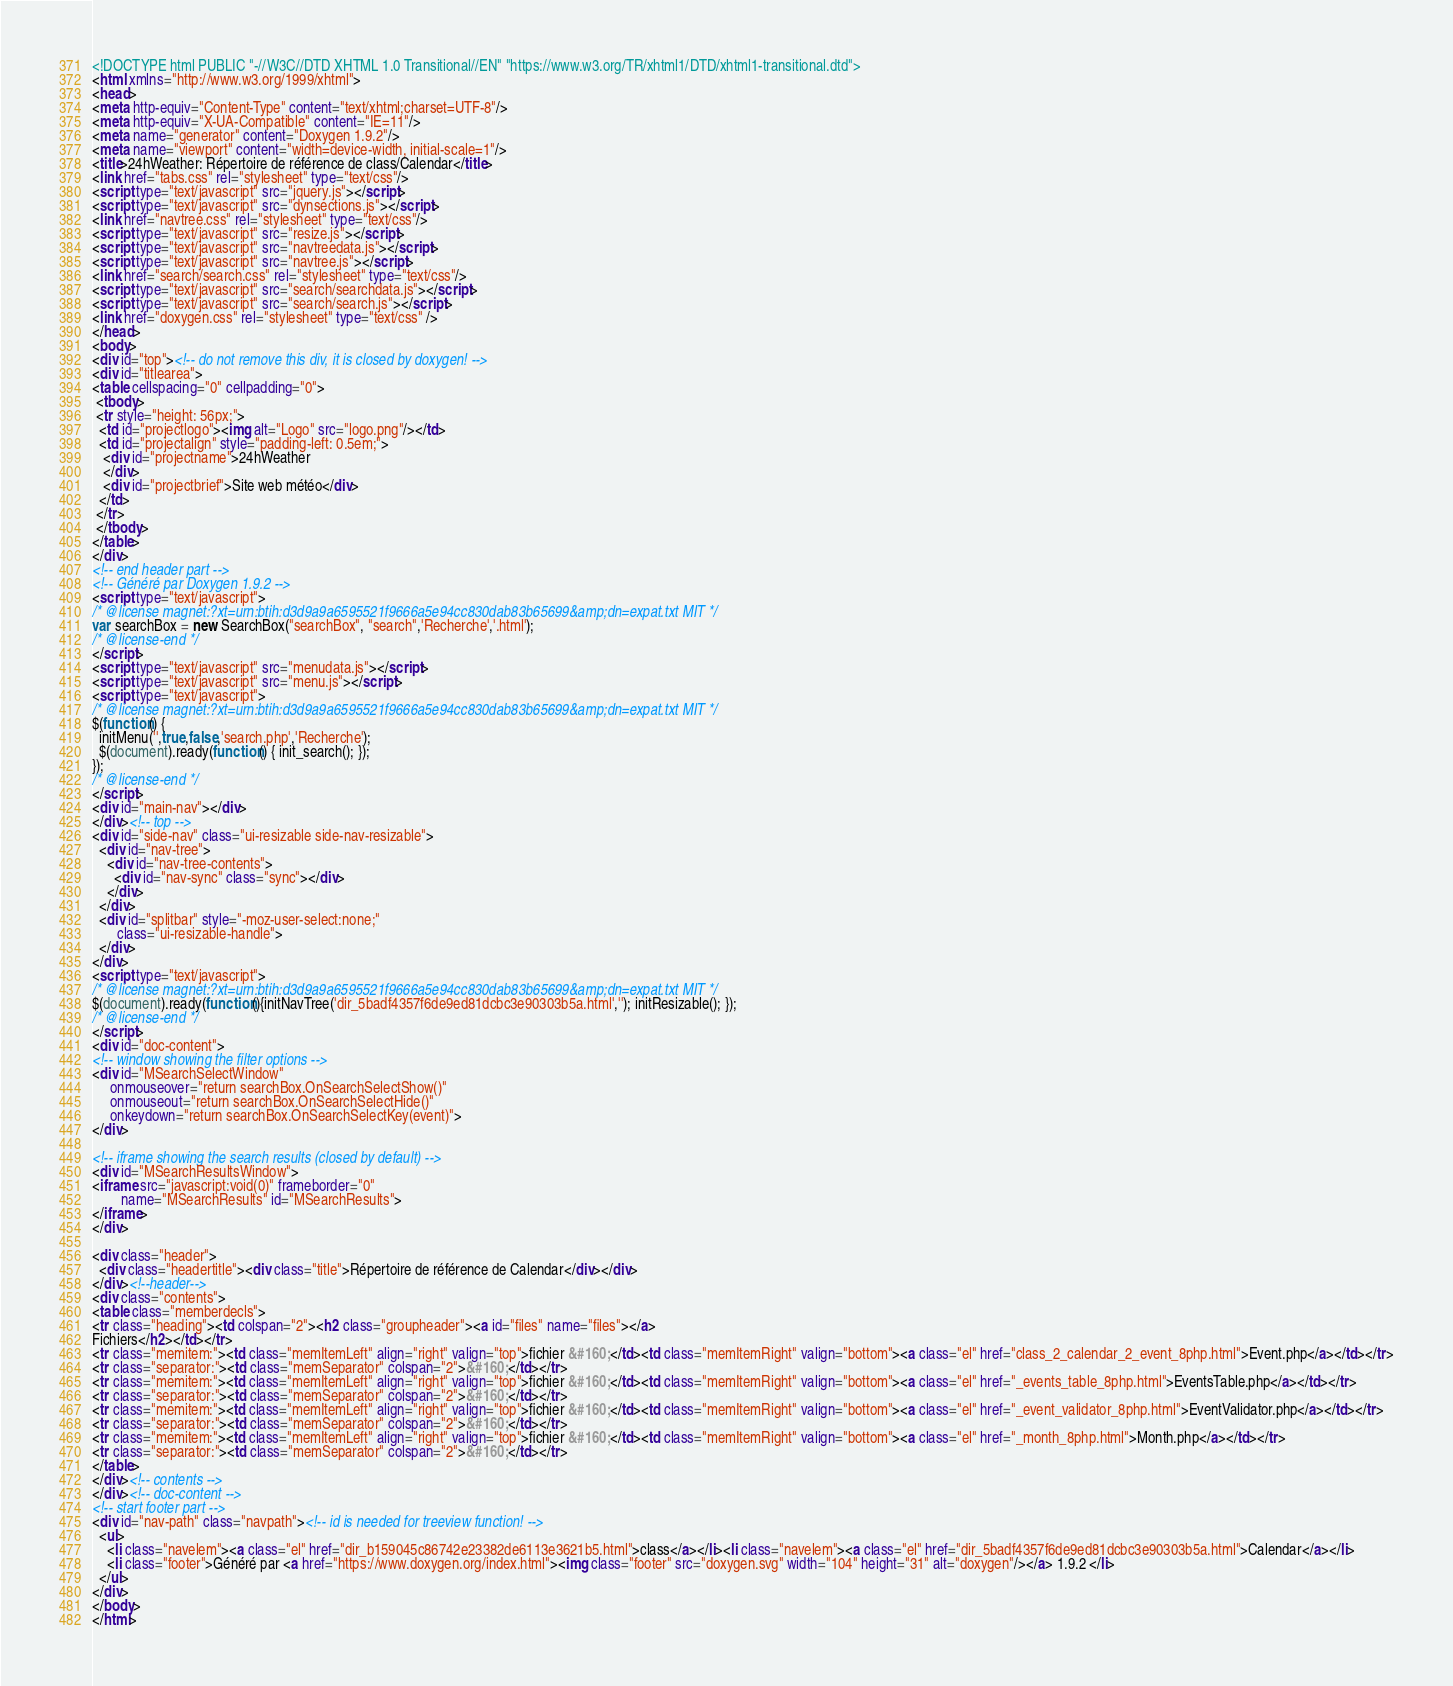Convert code to text. <code><loc_0><loc_0><loc_500><loc_500><_HTML_><!DOCTYPE html PUBLIC "-//W3C//DTD XHTML 1.0 Transitional//EN" "https://www.w3.org/TR/xhtml1/DTD/xhtml1-transitional.dtd">
<html xmlns="http://www.w3.org/1999/xhtml">
<head>
<meta http-equiv="Content-Type" content="text/xhtml;charset=UTF-8"/>
<meta http-equiv="X-UA-Compatible" content="IE=11"/>
<meta name="generator" content="Doxygen 1.9.2"/>
<meta name="viewport" content="width=device-width, initial-scale=1"/>
<title>24hWeather: Répertoire de référence de class/Calendar</title>
<link href="tabs.css" rel="stylesheet" type="text/css"/>
<script type="text/javascript" src="jquery.js"></script>
<script type="text/javascript" src="dynsections.js"></script>
<link href="navtree.css" rel="stylesheet" type="text/css"/>
<script type="text/javascript" src="resize.js"></script>
<script type="text/javascript" src="navtreedata.js"></script>
<script type="text/javascript" src="navtree.js"></script>
<link href="search/search.css" rel="stylesheet" type="text/css"/>
<script type="text/javascript" src="search/searchdata.js"></script>
<script type="text/javascript" src="search/search.js"></script>
<link href="doxygen.css" rel="stylesheet" type="text/css" />
</head>
<body>
<div id="top"><!-- do not remove this div, it is closed by doxygen! -->
<div id="titlearea">
<table cellspacing="0" cellpadding="0">
 <tbody>
 <tr style="height: 56px;">
  <td id="projectlogo"><img alt="Logo" src="logo.png"/></td>
  <td id="projectalign" style="padding-left: 0.5em;">
   <div id="projectname">24hWeather
   </div>
   <div id="projectbrief">Site web météo</div>
  </td>
 </tr>
 </tbody>
</table>
</div>
<!-- end header part -->
<!-- Généré par Doxygen 1.9.2 -->
<script type="text/javascript">
/* @license magnet:?xt=urn:btih:d3d9a9a6595521f9666a5e94cc830dab83b65699&amp;dn=expat.txt MIT */
var searchBox = new SearchBox("searchBox", "search",'Recherche','.html');
/* @license-end */
</script>
<script type="text/javascript" src="menudata.js"></script>
<script type="text/javascript" src="menu.js"></script>
<script type="text/javascript">
/* @license magnet:?xt=urn:btih:d3d9a9a6595521f9666a5e94cc830dab83b65699&amp;dn=expat.txt MIT */
$(function() {
  initMenu('',true,false,'search.php','Recherche');
  $(document).ready(function() { init_search(); });
});
/* @license-end */
</script>
<div id="main-nav"></div>
</div><!-- top -->
<div id="side-nav" class="ui-resizable side-nav-resizable">
  <div id="nav-tree">
    <div id="nav-tree-contents">
      <div id="nav-sync" class="sync"></div>
    </div>
  </div>
  <div id="splitbar" style="-moz-user-select:none;" 
       class="ui-resizable-handle">
  </div>
</div>
<script type="text/javascript">
/* @license magnet:?xt=urn:btih:d3d9a9a6595521f9666a5e94cc830dab83b65699&amp;dn=expat.txt MIT */
$(document).ready(function(){initNavTree('dir_5badf4357f6de9ed81dcbc3e90303b5a.html',''); initResizable(); });
/* @license-end */
</script>
<div id="doc-content">
<!-- window showing the filter options -->
<div id="MSearchSelectWindow"
     onmouseover="return searchBox.OnSearchSelectShow()"
     onmouseout="return searchBox.OnSearchSelectHide()"
     onkeydown="return searchBox.OnSearchSelectKey(event)">
</div>

<!-- iframe showing the search results (closed by default) -->
<div id="MSearchResultsWindow">
<iframe src="javascript:void(0)" frameborder="0" 
        name="MSearchResults" id="MSearchResults">
</iframe>
</div>

<div class="header">
  <div class="headertitle"><div class="title">Répertoire de référence de Calendar</div></div>
</div><!--header-->
<div class="contents">
<table class="memberdecls">
<tr class="heading"><td colspan="2"><h2 class="groupheader"><a id="files" name="files"></a>
Fichiers</h2></td></tr>
<tr class="memitem:"><td class="memItemLeft" align="right" valign="top">fichier &#160;</td><td class="memItemRight" valign="bottom"><a class="el" href="class_2_calendar_2_event_8php.html">Event.php</a></td></tr>
<tr class="separator:"><td class="memSeparator" colspan="2">&#160;</td></tr>
<tr class="memitem:"><td class="memItemLeft" align="right" valign="top">fichier &#160;</td><td class="memItemRight" valign="bottom"><a class="el" href="_events_table_8php.html">EventsTable.php</a></td></tr>
<tr class="separator:"><td class="memSeparator" colspan="2">&#160;</td></tr>
<tr class="memitem:"><td class="memItemLeft" align="right" valign="top">fichier &#160;</td><td class="memItemRight" valign="bottom"><a class="el" href="_event_validator_8php.html">EventValidator.php</a></td></tr>
<tr class="separator:"><td class="memSeparator" colspan="2">&#160;</td></tr>
<tr class="memitem:"><td class="memItemLeft" align="right" valign="top">fichier &#160;</td><td class="memItemRight" valign="bottom"><a class="el" href="_month_8php.html">Month.php</a></td></tr>
<tr class="separator:"><td class="memSeparator" colspan="2">&#160;</td></tr>
</table>
</div><!-- contents -->
</div><!-- doc-content -->
<!-- start footer part -->
<div id="nav-path" class="navpath"><!-- id is needed for treeview function! -->
  <ul>
    <li class="navelem"><a class="el" href="dir_b159045c86742e23382de6113e3621b5.html">class</a></li><li class="navelem"><a class="el" href="dir_5badf4357f6de9ed81dcbc3e90303b5a.html">Calendar</a></li>
    <li class="footer">Généré par <a href="https://www.doxygen.org/index.html"><img class="footer" src="doxygen.svg" width="104" height="31" alt="doxygen"/></a> 1.9.2 </li>
  </ul>
</div>
</body>
</html>
</code> 